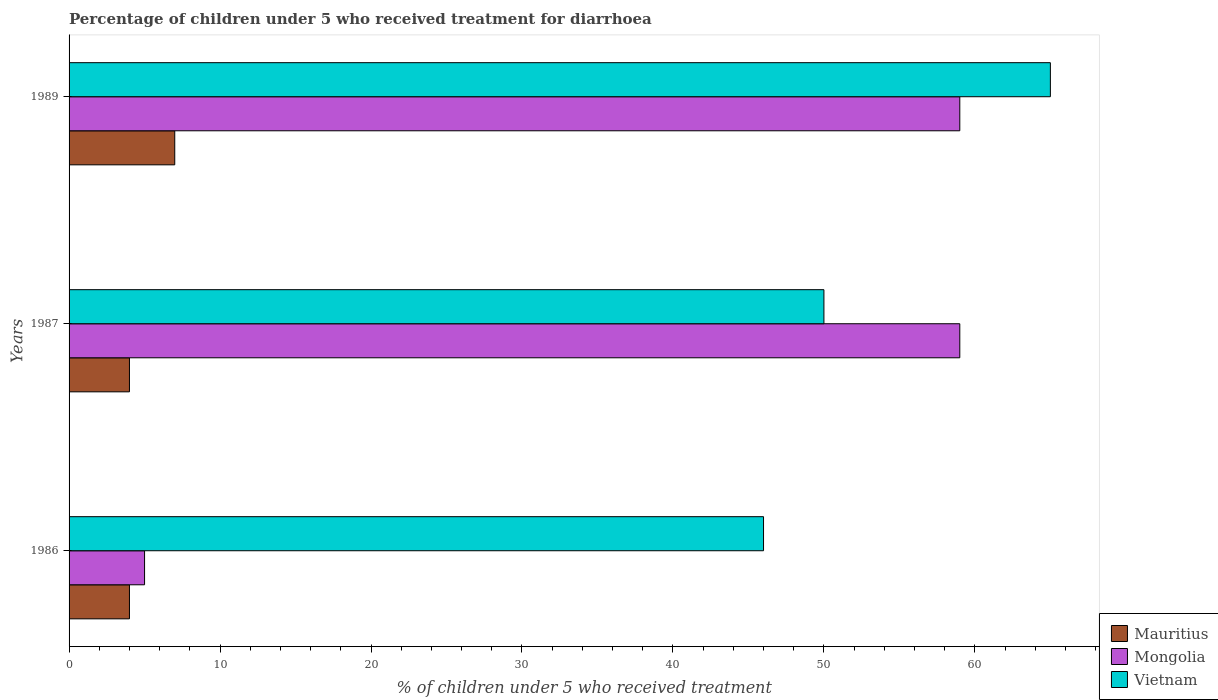How many different coloured bars are there?
Offer a terse response. 3. Are the number of bars on each tick of the Y-axis equal?
Give a very brief answer. Yes. How many bars are there on the 2nd tick from the top?
Ensure brevity in your answer.  3. How many bars are there on the 1st tick from the bottom?
Your answer should be very brief. 3. In how many cases, is the number of bars for a given year not equal to the number of legend labels?
Your response must be concise. 0. What is the percentage of children who received treatment for diarrhoea  in Vietnam in 1987?
Offer a terse response. 50. Across all years, what is the maximum percentage of children who received treatment for diarrhoea  in Mauritius?
Your response must be concise. 7. Across all years, what is the minimum percentage of children who received treatment for diarrhoea  in Mauritius?
Your answer should be very brief. 4. In which year was the percentage of children who received treatment for diarrhoea  in Mauritius minimum?
Provide a succinct answer. 1986. What is the total percentage of children who received treatment for diarrhoea  in Mongolia in the graph?
Provide a succinct answer. 123. What is the difference between the percentage of children who received treatment for diarrhoea  in Mongolia in 1986 and that in 1989?
Provide a succinct answer. -54. What is the difference between the percentage of children who received treatment for diarrhoea  in Vietnam in 1987 and the percentage of children who received treatment for diarrhoea  in Mongolia in 1989?
Your answer should be very brief. -9. What is the average percentage of children who received treatment for diarrhoea  in Vietnam per year?
Give a very brief answer. 53.67. In the year 1989, what is the difference between the percentage of children who received treatment for diarrhoea  in Vietnam and percentage of children who received treatment for diarrhoea  in Mongolia?
Make the answer very short. 6. In how many years, is the percentage of children who received treatment for diarrhoea  in Mauritius greater than 60 %?
Keep it short and to the point. 0. What is the ratio of the percentage of children who received treatment for diarrhoea  in Mongolia in 1986 to that in 1989?
Provide a short and direct response. 0.08. Is the difference between the percentage of children who received treatment for diarrhoea  in Vietnam in 1986 and 1989 greater than the difference between the percentage of children who received treatment for diarrhoea  in Mongolia in 1986 and 1989?
Your response must be concise. Yes. What is the difference between the highest and the second highest percentage of children who received treatment for diarrhoea  in Mongolia?
Ensure brevity in your answer.  0. What is the difference between the highest and the lowest percentage of children who received treatment for diarrhoea  in Vietnam?
Your response must be concise. 19. Is the sum of the percentage of children who received treatment for diarrhoea  in Mongolia in 1986 and 1987 greater than the maximum percentage of children who received treatment for diarrhoea  in Vietnam across all years?
Your answer should be very brief. No. What does the 1st bar from the top in 1989 represents?
Ensure brevity in your answer.  Vietnam. What does the 1st bar from the bottom in 1987 represents?
Your answer should be very brief. Mauritius. How many bars are there?
Provide a succinct answer. 9. Are all the bars in the graph horizontal?
Provide a succinct answer. Yes. What is the difference between two consecutive major ticks on the X-axis?
Your response must be concise. 10. Are the values on the major ticks of X-axis written in scientific E-notation?
Your answer should be very brief. No. Does the graph contain grids?
Ensure brevity in your answer.  No. Where does the legend appear in the graph?
Give a very brief answer. Bottom right. What is the title of the graph?
Offer a terse response. Percentage of children under 5 who received treatment for diarrhoea. What is the label or title of the X-axis?
Keep it short and to the point. % of children under 5 who received treatment. What is the label or title of the Y-axis?
Your answer should be compact. Years. What is the % of children under 5 who received treatment of Mauritius in 1986?
Ensure brevity in your answer.  4. What is the % of children under 5 who received treatment of Mongolia in 1986?
Provide a short and direct response. 5. What is the % of children under 5 who received treatment in Mauritius in 1987?
Offer a very short reply. 4. What is the % of children under 5 who received treatment in Mongolia in 1987?
Your answer should be very brief. 59. What is the % of children under 5 who received treatment of Vietnam in 1987?
Make the answer very short. 50. What is the % of children under 5 who received treatment of Mauritius in 1989?
Your answer should be compact. 7. What is the % of children under 5 who received treatment of Vietnam in 1989?
Offer a very short reply. 65. Across all years, what is the maximum % of children under 5 who received treatment of Vietnam?
Make the answer very short. 65. Across all years, what is the minimum % of children under 5 who received treatment in Mauritius?
Offer a terse response. 4. What is the total % of children under 5 who received treatment in Mauritius in the graph?
Provide a short and direct response. 15. What is the total % of children under 5 who received treatment of Mongolia in the graph?
Ensure brevity in your answer.  123. What is the total % of children under 5 who received treatment in Vietnam in the graph?
Your response must be concise. 161. What is the difference between the % of children under 5 who received treatment in Mauritius in 1986 and that in 1987?
Your response must be concise. 0. What is the difference between the % of children under 5 who received treatment of Mongolia in 1986 and that in 1987?
Provide a succinct answer. -54. What is the difference between the % of children under 5 who received treatment of Mauritius in 1986 and that in 1989?
Offer a terse response. -3. What is the difference between the % of children under 5 who received treatment of Mongolia in 1986 and that in 1989?
Keep it short and to the point. -54. What is the difference between the % of children under 5 who received treatment in Mauritius in 1987 and that in 1989?
Ensure brevity in your answer.  -3. What is the difference between the % of children under 5 who received treatment of Vietnam in 1987 and that in 1989?
Offer a very short reply. -15. What is the difference between the % of children under 5 who received treatment of Mauritius in 1986 and the % of children under 5 who received treatment of Mongolia in 1987?
Your answer should be compact. -55. What is the difference between the % of children under 5 who received treatment of Mauritius in 1986 and the % of children under 5 who received treatment of Vietnam in 1987?
Give a very brief answer. -46. What is the difference between the % of children under 5 who received treatment of Mongolia in 1986 and the % of children under 5 who received treatment of Vietnam in 1987?
Give a very brief answer. -45. What is the difference between the % of children under 5 who received treatment of Mauritius in 1986 and the % of children under 5 who received treatment of Mongolia in 1989?
Provide a short and direct response. -55. What is the difference between the % of children under 5 who received treatment in Mauritius in 1986 and the % of children under 5 who received treatment in Vietnam in 1989?
Provide a succinct answer. -61. What is the difference between the % of children under 5 who received treatment in Mongolia in 1986 and the % of children under 5 who received treatment in Vietnam in 1989?
Make the answer very short. -60. What is the difference between the % of children under 5 who received treatment of Mauritius in 1987 and the % of children under 5 who received treatment of Mongolia in 1989?
Provide a succinct answer. -55. What is the difference between the % of children under 5 who received treatment in Mauritius in 1987 and the % of children under 5 who received treatment in Vietnam in 1989?
Provide a short and direct response. -61. What is the difference between the % of children under 5 who received treatment of Mongolia in 1987 and the % of children under 5 who received treatment of Vietnam in 1989?
Your response must be concise. -6. What is the average % of children under 5 who received treatment of Mongolia per year?
Provide a short and direct response. 41. What is the average % of children under 5 who received treatment in Vietnam per year?
Offer a terse response. 53.67. In the year 1986, what is the difference between the % of children under 5 who received treatment of Mauritius and % of children under 5 who received treatment of Vietnam?
Provide a succinct answer. -42. In the year 1986, what is the difference between the % of children under 5 who received treatment of Mongolia and % of children under 5 who received treatment of Vietnam?
Ensure brevity in your answer.  -41. In the year 1987, what is the difference between the % of children under 5 who received treatment of Mauritius and % of children under 5 who received treatment of Mongolia?
Your answer should be compact. -55. In the year 1987, what is the difference between the % of children under 5 who received treatment in Mauritius and % of children under 5 who received treatment in Vietnam?
Your answer should be very brief. -46. In the year 1989, what is the difference between the % of children under 5 who received treatment in Mauritius and % of children under 5 who received treatment in Mongolia?
Make the answer very short. -52. In the year 1989, what is the difference between the % of children under 5 who received treatment in Mauritius and % of children under 5 who received treatment in Vietnam?
Keep it short and to the point. -58. In the year 1989, what is the difference between the % of children under 5 who received treatment of Mongolia and % of children under 5 who received treatment of Vietnam?
Your answer should be very brief. -6. What is the ratio of the % of children under 5 who received treatment in Mongolia in 1986 to that in 1987?
Provide a short and direct response. 0.08. What is the ratio of the % of children under 5 who received treatment of Vietnam in 1986 to that in 1987?
Your response must be concise. 0.92. What is the ratio of the % of children under 5 who received treatment in Mongolia in 1986 to that in 1989?
Keep it short and to the point. 0.08. What is the ratio of the % of children under 5 who received treatment in Vietnam in 1986 to that in 1989?
Offer a terse response. 0.71. What is the ratio of the % of children under 5 who received treatment in Mauritius in 1987 to that in 1989?
Give a very brief answer. 0.57. What is the ratio of the % of children under 5 who received treatment of Mongolia in 1987 to that in 1989?
Offer a terse response. 1. What is the ratio of the % of children under 5 who received treatment of Vietnam in 1987 to that in 1989?
Your answer should be compact. 0.77. What is the difference between the highest and the second highest % of children under 5 who received treatment of Mauritius?
Your response must be concise. 3. What is the difference between the highest and the second highest % of children under 5 who received treatment in Mongolia?
Your response must be concise. 0. What is the difference between the highest and the second highest % of children under 5 who received treatment in Vietnam?
Your answer should be compact. 15. What is the difference between the highest and the lowest % of children under 5 who received treatment of Mongolia?
Make the answer very short. 54. What is the difference between the highest and the lowest % of children under 5 who received treatment in Vietnam?
Ensure brevity in your answer.  19. 